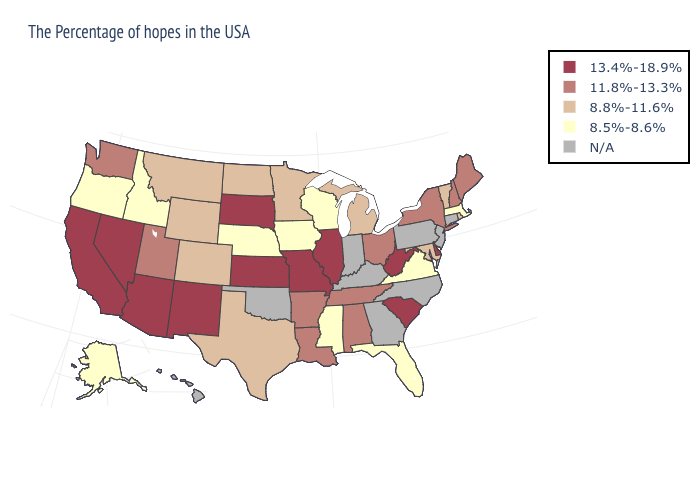Among the states that border Montana , does Idaho have the lowest value?
Write a very short answer. Yes. Is the legend a continuous bar?
Give a very brief answer. No. Does the map have missing data?
Quick response, please. Yes. What is the value of Wyoming?
Be succinct. 8.8%-11.6%. Among the states that border Alabama , does Tennessee have the lowest value?
Be succinct. No. Name the states that have a value in the range 8.5%-8.6%?
Quick response, please. Massachusetts, Virginia, Florida, Wisconsin, Mississippi, Iowa, Nebraska, Idaho, Oregon, Alaska. Name the states that have a value in the range N/A?
Write a very short answer. Connecticut, New Jersey, Pennsylvania, North Carolina, Georgia, Kentucky, Indiana, Oklahoma, Hawaii. Name the states that have a value in the range 11.8%-13.3%?
Quick response, please. Maine, New Hampshire, New York, Ohio, Alabama, Tennessee, Louisiana, Arkansas, Utah, Washington. Which states have the lowest value in the South?
Quick response, please. Virginia, Florida, Mississippi. What is the value of Alabama?
Be succinct. 11.8%-13.3%. Does the map have missing data?
Keep it brief. Yes. Among the states that border Kentucky , does Virginia have the highest value?
Answer briefly. No. Name the states that have a value in the range 11.8%-13.3%?
Concise answer only. Maine, New Hampshire, New York, Ohio, Alabama, Tennessee, Louisiana, Arkansas, Utah, Washington. Does the first symbol in the legend represent the smallest category?
Keep it brief. No. Name the states that have a value in the range N/A?
Concise answer only. Connecticut, New Jersey, Pennsylvania, North Carolina, Georgia, Kentucky, Indiana, Oklahoma, Hawaii. 